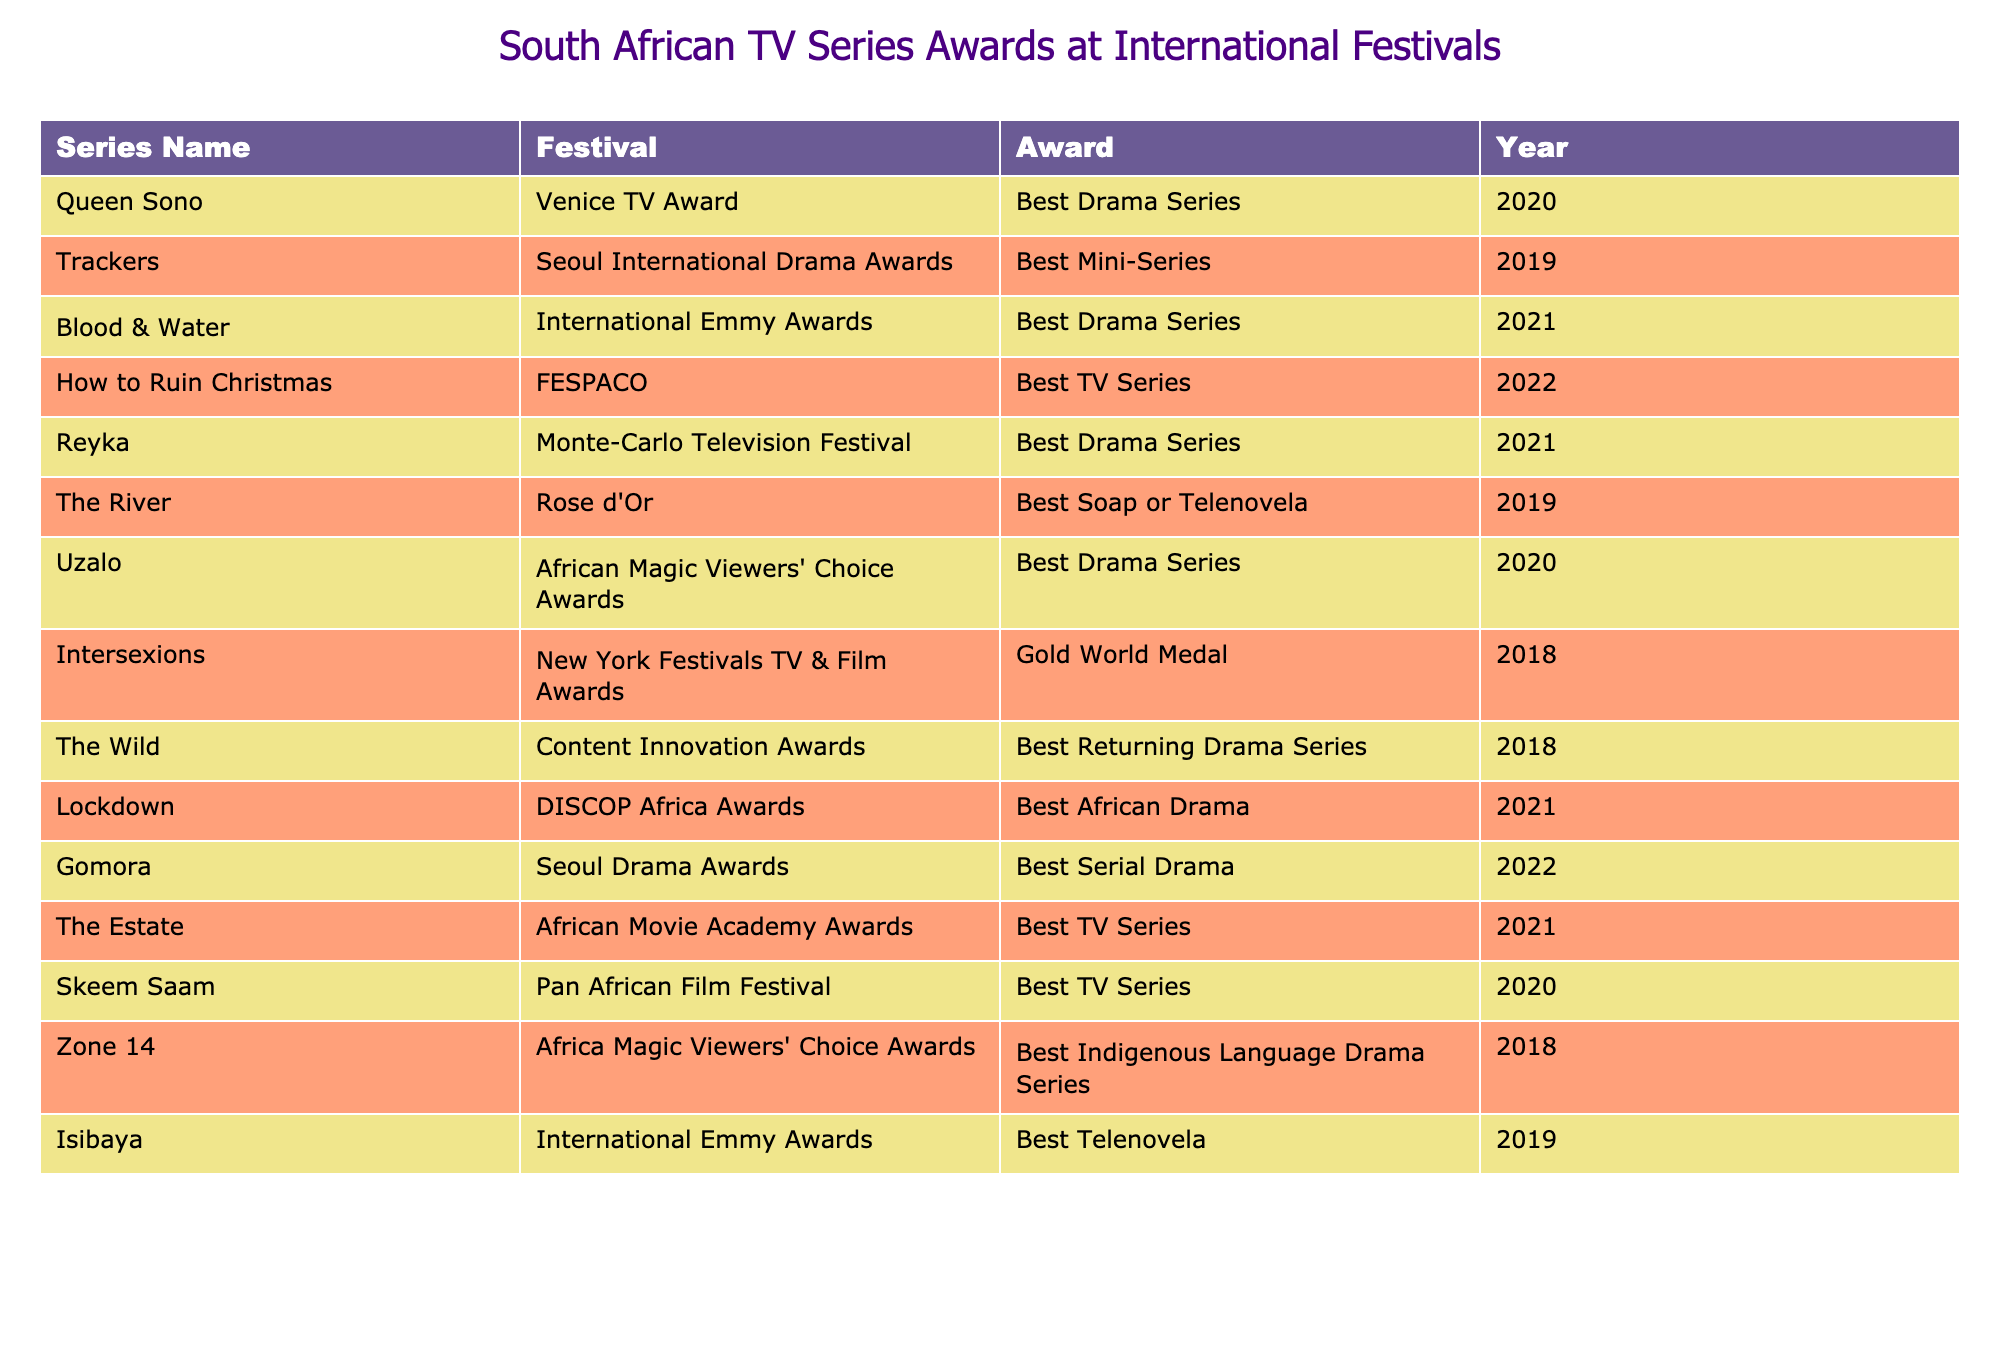What award did "Queen Sono" win at the Venice TV Award? The table shows that "Queen Sono" won the award for Best Drama Series at the Venice TV Award in 2020.
Answer: Best Drama Series How many awards did "Blood & Water" win, and at which festival? The table indicates that "Blood & Water" won one award, the Best Drama Series at the International Emmy Awards in 2021.
Answer: 1 award at the International Emmy Awards Is "Gomora" awarded at the Seoul Drama Awards? The table shows that "Gomora" won the Best Serial Drama at the Seoul Drama Awards in 2022, confirming it was awarded.
Answer: Yes Which series won the best TV series award at FESPACO? According to the table, "How to Ruin Christmas" won the Best TV Series award at FESPACO in 2022.
Answer: How to Ruin Christmas What is the total number of awards won by the series listed in 2021? The table indicates that three series won awards in 2021: "Blood & Water," "Lockdown," and "The Estate" (totaling 3 awards).
Answer: 3 awards Did "Isibaya" win the Best Telenovela award at the International Emmy Awards? The table shows that "Isibaya" did win the Best Telenovela award at the International Emmy Awards in 2019.
Answer: Yes Which festival had the most awards won by South African series based on the table? Analyzing the festivals in the table, the most prominent awards are at the International Emmy Awards, Seoul International Drama Awards, and FESPACO where multiple series won, but each only won once. Therefore, there is no single festival that stands out with the most awards.
Answer: No single festival stands out Which series received an award for Best Returning Drama Series? The table indicates that "The Wild" received the Best Returning Drama Series award at the Content Innovation Awards in 2018.
Answer: The Wild What is the average number of awards won per year by the South African series in the provided data? The awards are distributed in 7 different years from the data. Among those years, the total counts are as follows: 1 for 2018, 6 for 2019, 2 for 2020, 2 for 2021, and 2 for 2022, totaling 13 awards across 5 years which averages out at 13/5 = 2.6.
Answer: 2.6 awards per year Which series was awarded at the African Magic Viewers' Choice Awards? According to the table, "Uzalo" won the Best Drama Series at the African Magic Viewers' Choice Awards in 2020 as indicated.
Answer: Uzalo 